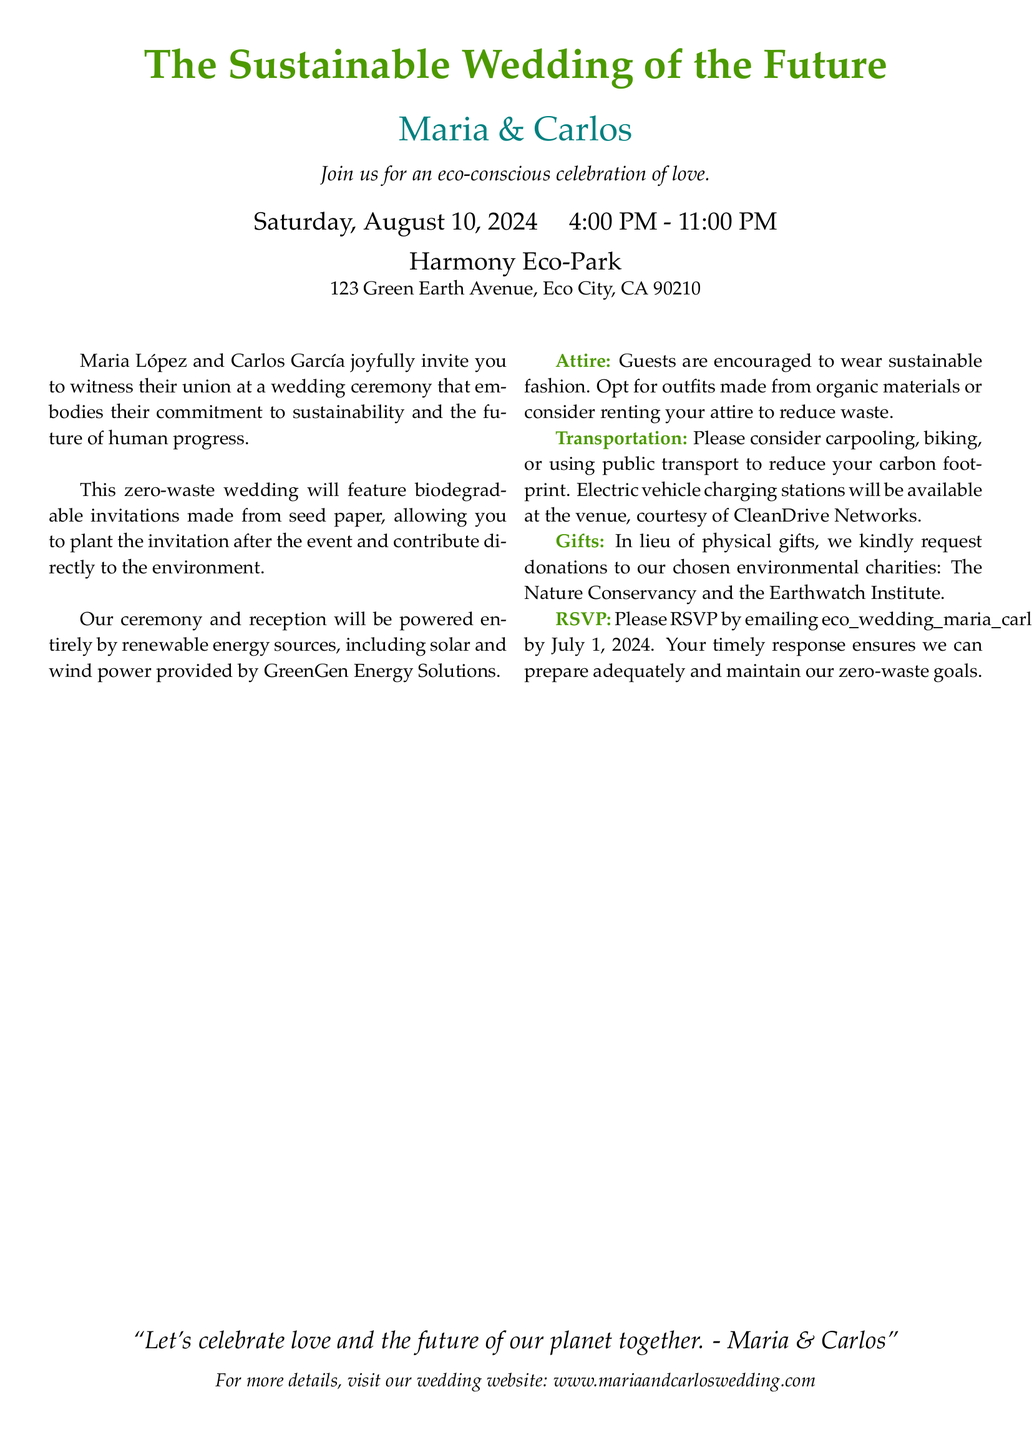What is the date of the wedding? The wedding is scheduled for Saturday, August 10, 2024.
Answer: August 10, 2024 What time does the wedding start? The ceremony begins at 4:00 PM.
Answer: 4:00 PM Where is the wedding taking place? The wedding will be held at Harmony Eco-Park, located at 123 Green Earth Avenue, Eco City, CA 90210.
Answer: Harmony Eco-Park What type of invitations are being used? The invitations are biodegradable and made from seed paper.
Answer: Seed paper What is requested instead of physical gifts? The couple requests donations to environmental charities.
Answer: Donations to environmental charities How are guests encouraged to arrive at the venue? Guests are encouraged to consider carpooling, biking, or using public transport.
Answer: Carpooling, biking, or public transport What type of energy will power the reception? The reception will be powered entirely by renewable energy sources.
Answer: Renewable energy sources What is the RSVP deadline? The RSVP deadline is July 1, 2024.
Answer: July 1, 2024 What is the couple's message about the celebration? The couple's message emphasizes celebrating love and the future of the planet.
Answer: Celebrate love and the future of our planet 